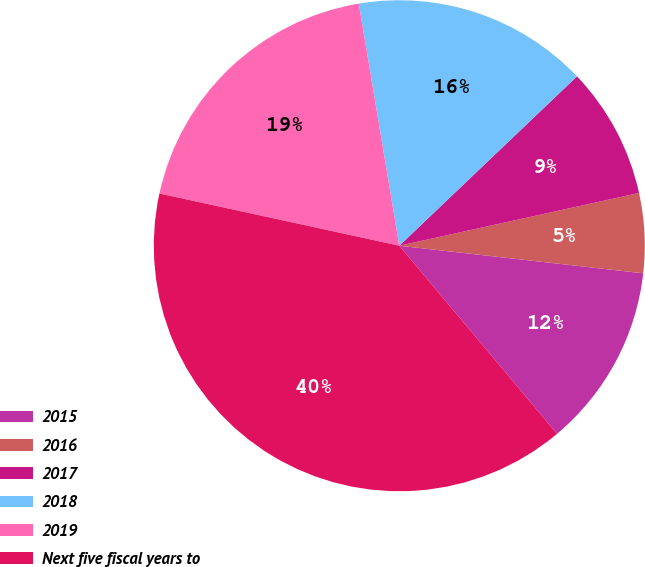Convert chart to OTSL. <chart><loc_0><loc_0><loc_500><loc_500><pie_chart><fcel>2015<fcel>2016<fcel>2017<fcel>2018<fcel>2019<fcel>Next five fiscal years to<nl><fcel>12.1%<fcel>5.24%<fcel>8.67%<fcel>15.52%<fcel>18.95%<fcel>39.52%<nl></chart> 